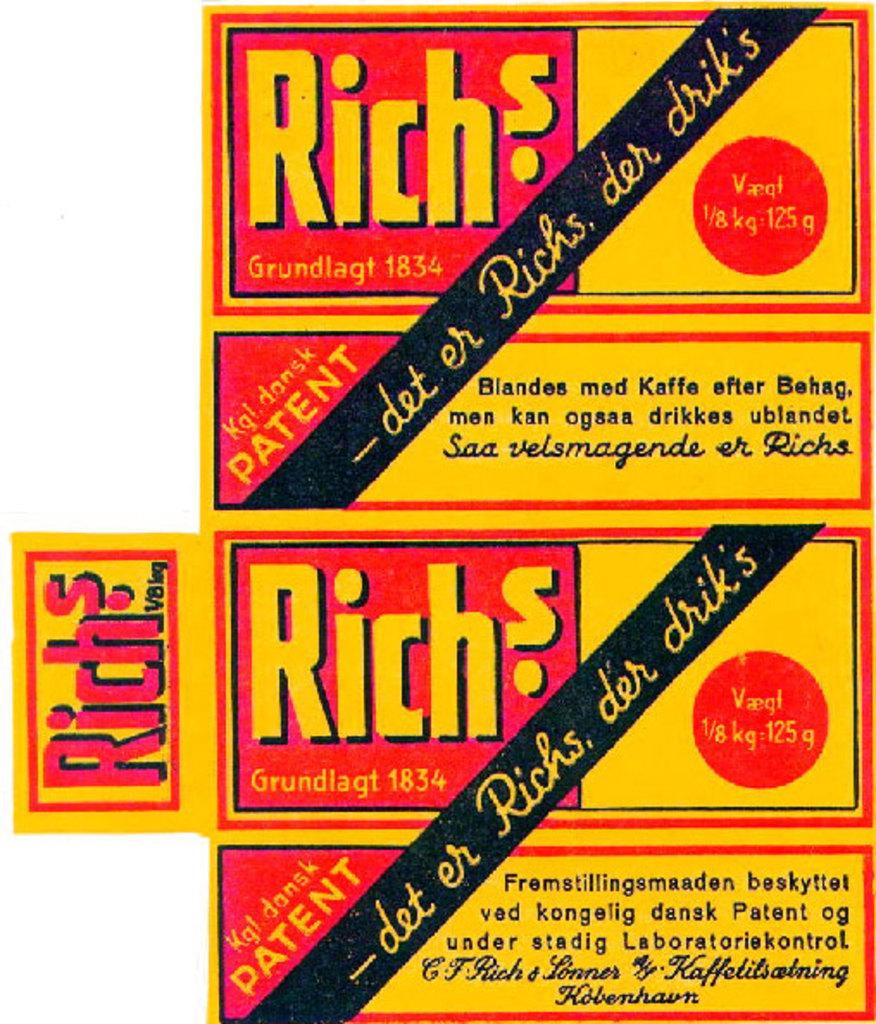Provide a one-sentence caption for the provided image. Orange and red Rich's label written in German. 